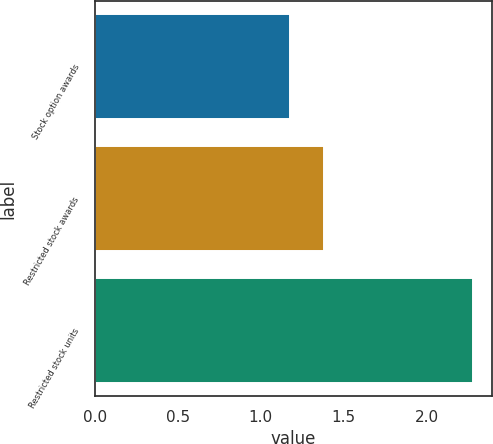<chart> <loc_0><loc_0><loc_500><loc_500><bar_chart><fcel>Stock option awards<fcel>Restricted stock awards<fcel>Restricted stock units<nl><fcel>1.18<fcel>1.38<fcel>2.28<nl></chart> 